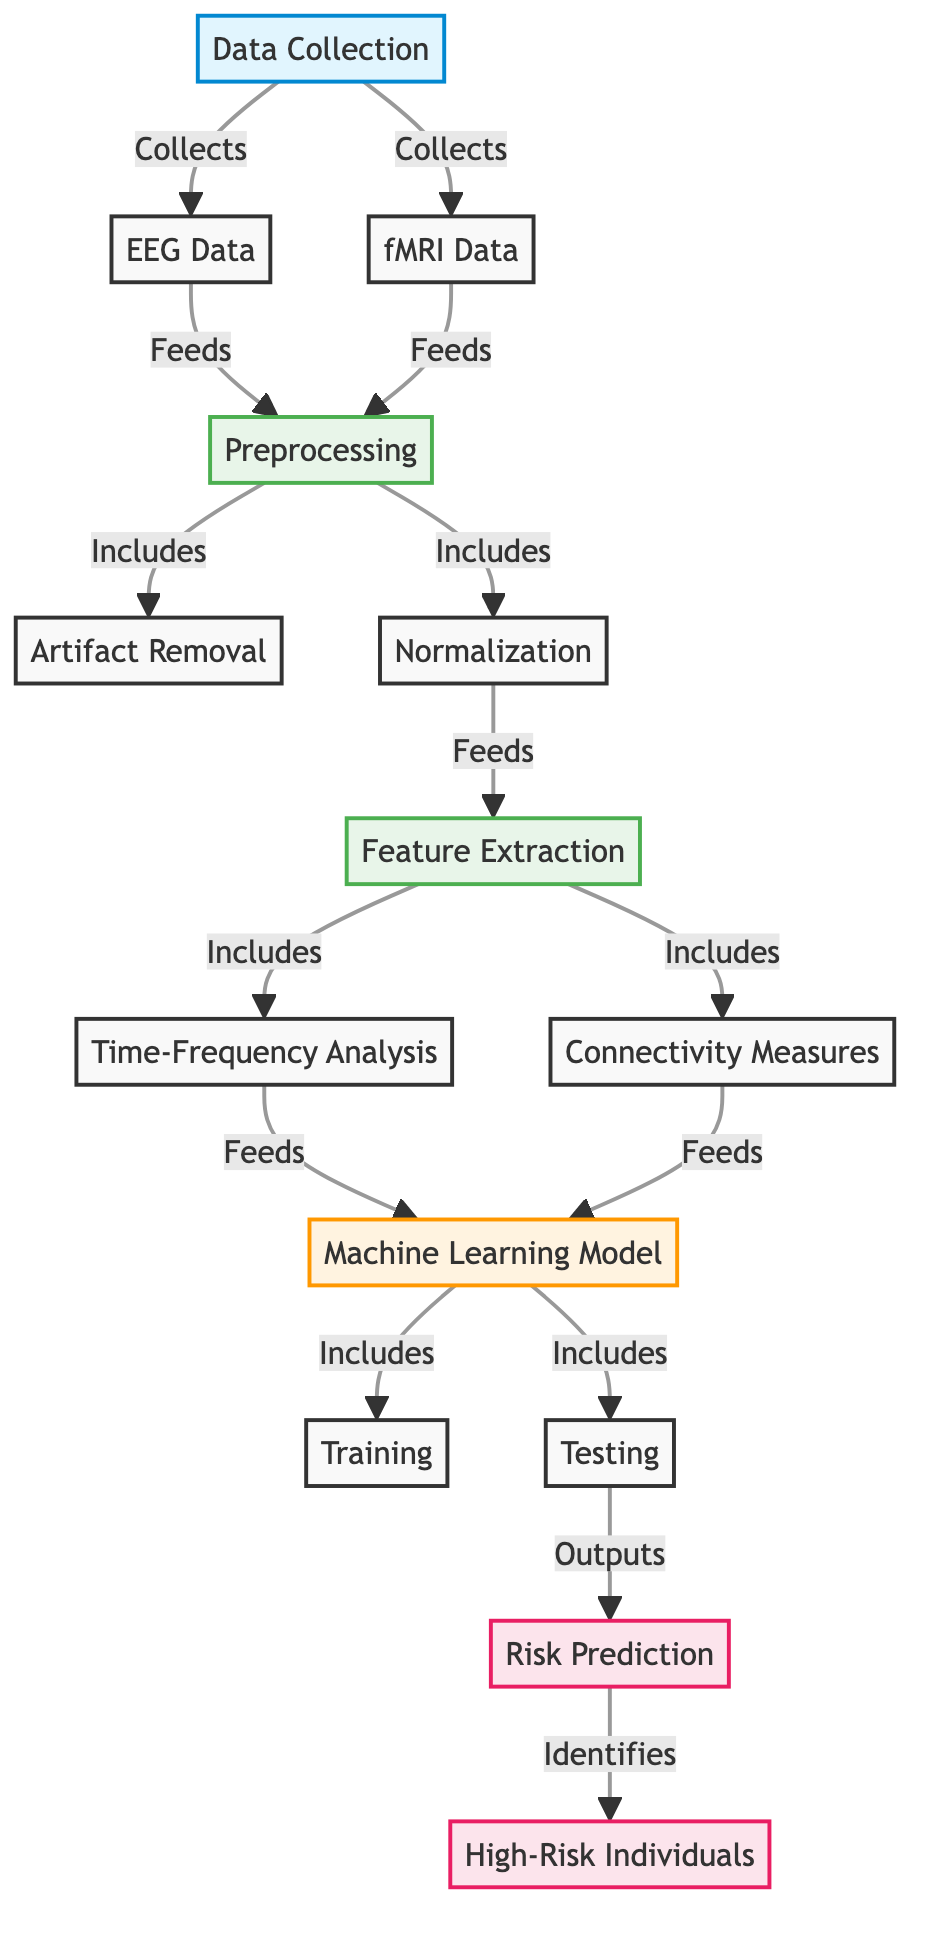What are the two types of data collected? The diagram indicates that EEG data and fMRI data are the two types involved in the data collection process.
Answer: EEG data, fMRI data How many preprocessing steps are there in the diagram? The diagram shows that there are two preprocessing steps: artifact removal and normalization, making a total of two.
Answer: 2 What does the feature extraction step include? According to the diagram, the feature extraction step includes time-frequency analysis and connectivity measures.
Answer: Time-frequency analysis, connectivity measures Which process directly precedes risk prediction? The diagram indicates that testing is the process that occurs directly before the risk prediction stage.
Answer: Testing What is the output of the predictive model? Based on the final outputs shown in the diagram, the predictive model identifies high-risk individuals for substance abuse disorders.
Answer: High-Risk Individuals How are EEG and fMRI data utilized in the model? EEG and fMRI data are collected and then fed into the preprocessing step, which prepares the data for the feature extraction that follows.
Answer: Fed into preprocessing What is the relationship between feature extraction and the machine learning model? Feature extraction supplies the processed data (from time-frequency analysis and connectivity measures) as input for the machine learning model to operate on.
Answer: Supplies input What is the main purpose of the machine learning model in this diagram? The purpose of the machine learning model, as specified in the diagram, is to conduct training and testing, leading to risk predictions regarding substance abuse disorders.
Answer: Risk predictions 